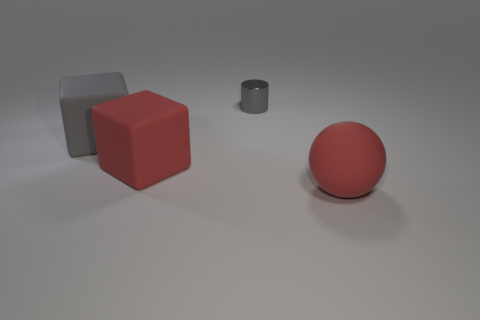Subtract all purple spheres. Subtract all green cylinders. How many spheres are left? 1 Add 2 spheres. How many objects exist? 6 Subtract all spheres. How many objects are left? 3 Subtract all large rubber blocks. Subtract all large red blocks. How many objects are left? 1 Add 3 big red blocks. How many big red blocks are left? 4 Add 3 gray things. How many gray things exist? 5 Subtract 0 green spheres. How many objects are left? 4 